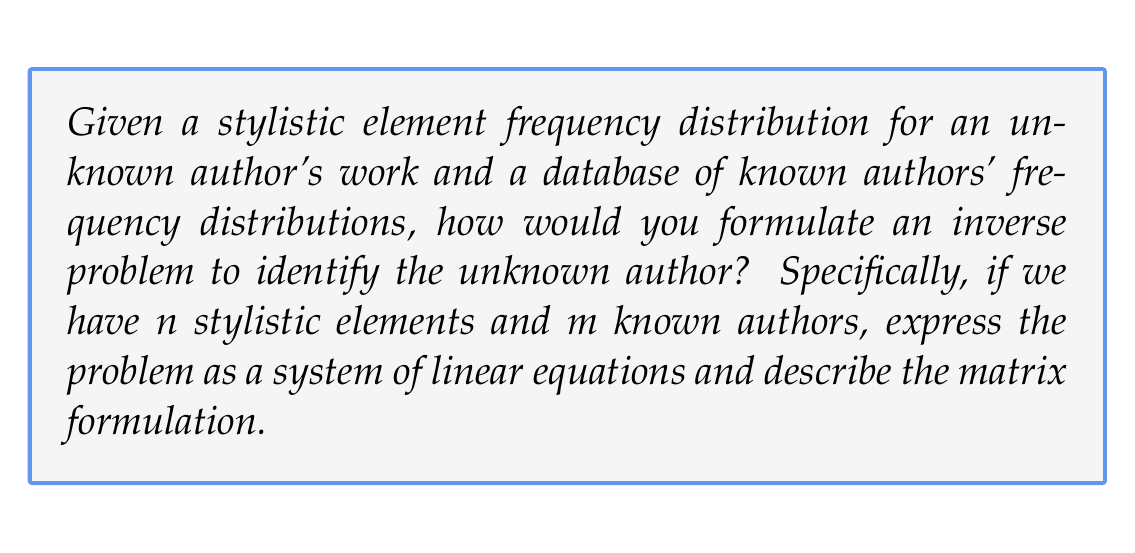Can you solve this math problem? To formulate this problem as an inverse problem, we'll follow these steps:

1) Let $x_i$ represent the unknown author's frequency of using stylistic element $i$, where $i = 1, 2, ..., n$.

2) Let $a_{ij}$ represent the frequency of stylistic element $i$ used by known author $j$, where $j = 1, 2, ..., m$.

3) We want to find a linear combination of known authors that best approximates the unknown author's style. Let $c_j$ be the coefficient for author $j$ in this linear combination.

4) We can express this as a system of linear equations:

   $$x_1 = a_{11}c_1 + a_{12}c_2 + ... + a_{1m}c_m$$
   $$x_2 = a_{21}c_1 + a_{22}c_2 + ... + a_{2m}c_m$$
   $$\vdots$$
   $$x_n = a_{n1}c_1 + a_{n2}c_2 + ... + a_{nm}c_m$$

5) In matrix form, this becomes:

   $$\begin{bmatrix} x_1 \\ x_2 \\ \vdots \\ x_n \end{bmatrix} = \begin{bmatrix} a_{11} & a_{12} & \cdots & a_{1m} \\ a_{21} & a_{22} & \cdots & a_{2m} \\ \vdots & \vdots & \ddots & \vdots \\ a_{n1} & a_{n2} & \cdots & a_{nm} \end{bmatrix} \begin{bmatrix} c_1 \\ c_2 \\ \vdots \\ c_m \end{bmatrix}$$

6) This can be written more compactly as:

   $$x = Ac$$

   where $x$ is the vector of unknown author's frequencies, $A$ is the matrix of known authors' frequencies, and $c$ is the vector of coefficients we're trying to determine.

7) The inverse problem is to find $c$ given $x$ and $A$. This is typically an ill-posed problem, especially if $n \neq m$, and may require regularization techniques to solve.
Answer: $x = Ac$, where $x \in \mathbb{R}^n$, $A \in \mathbb{R}^{n \times m}$, $c \in \mathbb{R}^m$ 